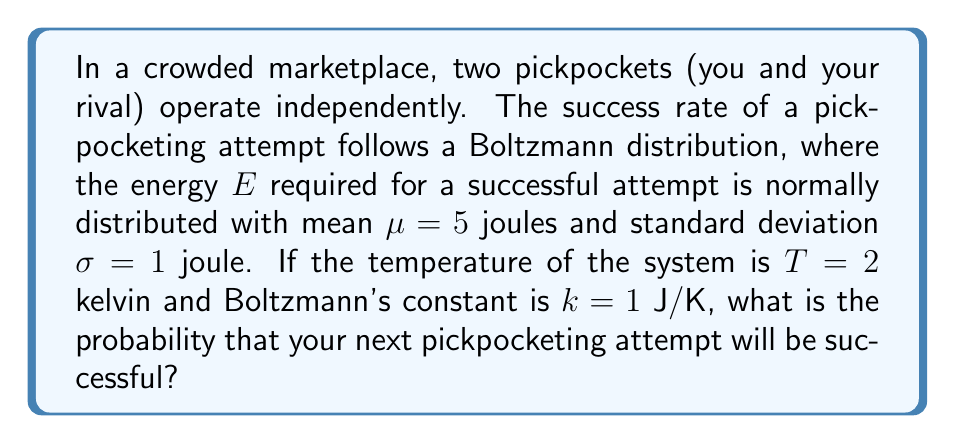Show me your answer to this math problem. 1) The Boltzmann distribution gives the probability of a system being in a state with energy $E$:

   $$P(E) = \frac{1}{Z} e^{-E/kT}$$

   where $Z$ is the partition function.

2) In this case, $E$ is normally distributed with $\mu = 5$ J and $\sigma = 1$ J. The probability density function for $E$ is:

   $$f(E) = \frac{1}{\sigma\sqrt{2\pi}} e^{-(E-\mu)^2/(2\sigma^2)}$$

3) The probability of a successful pickpocketing attempt is the expectation value of $P(E)$ over all possible energies:

   $$P(\text{success}) = \int_{-\infty}^{\infty} P(E) f(E) dE$$

4) Substituting the expressions:

   $$P(\text{success}) = \int_{-\infty}^{\infty} \frac{1}{Z} e^{-E/kT} \cdot \frac{1}{\sigma\sqrt{2\pi}} e^{-(E-\mu)^2/(2\sigma^2)} dE$$

5) Simplifying the exponent:

   $$\frac{E}{kT} + \frac{(E-\mu)^2}{2\sigma^2} = \frac{E^2}{2\sigma^2} - \frac{E\mu}{\sigma^2} + \frac{\mu^2}{2\sigma^2} + \frac{E}{kT}$$
   
   $$= \frac{E^2}{2\sigma^2} + E(\frac{1}{kT} - \frac{\mu}{\sigma^2}) + \frac{\mu^2}{2\sigma^2}$$

6) Completing the square:

   $$= \frac{(E + \sigma^2(\frac{1}{kT} - \frac{\mu}{\sigma^2}))^2}{2\sigma^2} + \frac{\mu^2}{2\sigma^2} - \frac{\sigma^2(\frac{1}{kT} - \frac{\mu}{\sigma^2})^2}{2}$$

7) The integral can now be evaluated:

   $$P(\text{success}) = \frac{1}{Z} e^{-\frac{\mu^2}{2\sigma^2} + \frac{\sigma^2(\frac{1}{kT} - \frac{\mu}{\sigma^2})^2}{2}}$$

8) Substituting the values: $\mu = 5$ J, $\sigma = 1$ J, $k = 1$ J/K, $T = 2$ K

   $$P(\text{success}) = \frac{1}{Z} e^{-\frac{25}{2} + \frac{(0.5 - 5)^2}{2}} = \frac{1}{Z} e^{-12.5 + 10.125} = \frac{1}{Z} e^{-2.375}$$

9) The partition function $Z$ normalizes the probability, so:

   $$P(\text{success}) = e^{-2.375} \approx 0.0931$$
Answer: 0.0931 